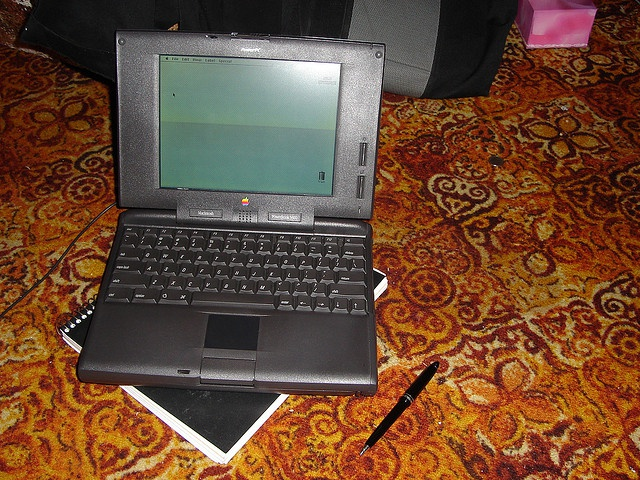Describe the objects in this image and their specific colors. I can see bed in black, maroon, and brown tones, laptop in black, gray, darkgray, and teal tones, and book in black, white, maroon, and gray tones in this image. 